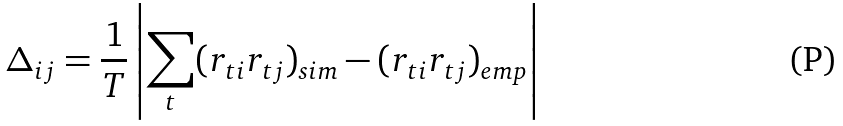Convert formula to latex. <formula><loc_0><loc_0><loc_500><loc_500>\Delta _ { i j } = \frac { 1 } { T } \left | \sum _ { t } ( r _ { t i } r _ { t j } ) _ { s i m } - ( r _ { t i } r _ { t j } ) _ { e m p } \right |</formula> 